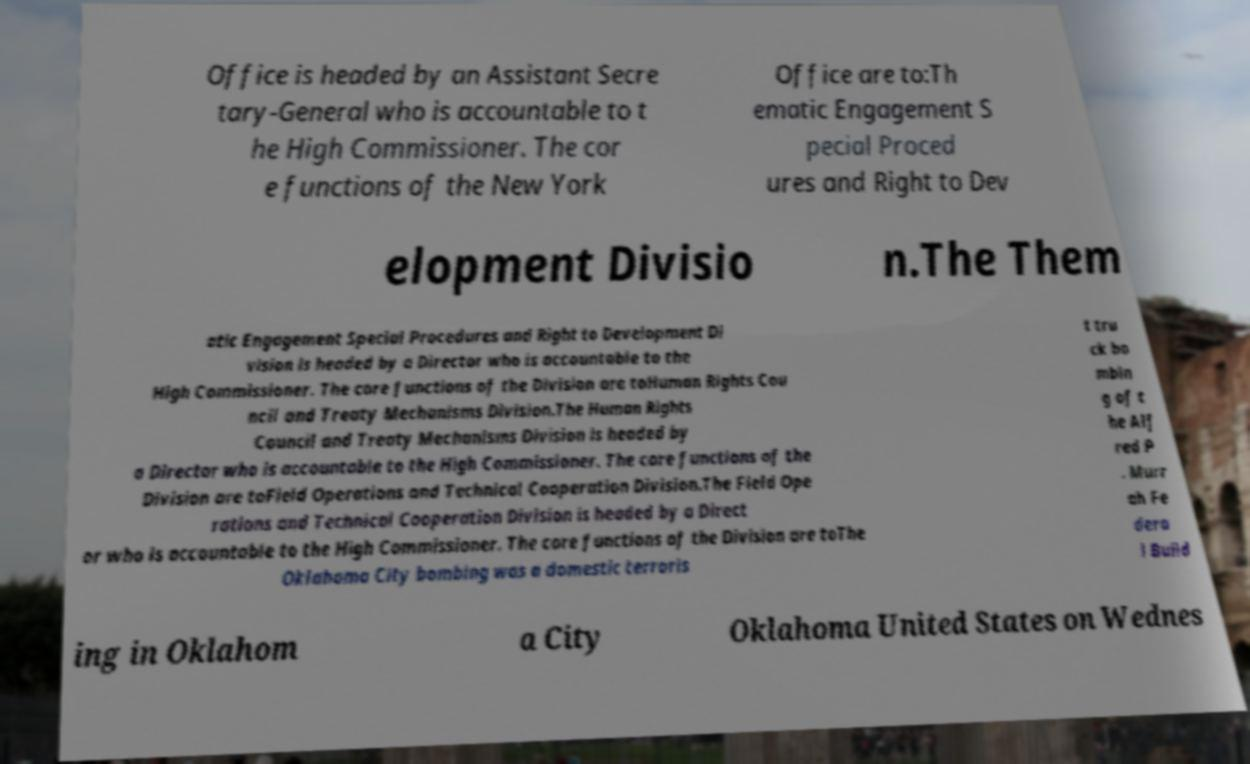Can you accurately transcribe the text from the provided image for me? Office is headed by an Assistant Secre tary-General who is accountable to t he High Commissioner. The cor e functions of the New York Office are to:Th ematic Engagement S pecial Proced ures and Right to Dev elopment Divisio n.The Them atic Engagement Special Procedures and Right to Development Di vision is headed by a Director who is accountable to the High Commissioner. The core functions of the Division are toHuman Rights Cou ncil and Treaty Mechanisms Division.The Human Rights Council and Treaty Mechanisms Division is headed by a Director who is accountable to the High Commissioner. The core functions of the Division are toField Operations and Technical Cooperation Division.The Field Ope rations and Technical Cooperation Division is headed by a Direct or who is accountable to the High Commissioner. The core functions of the Division are toThe Oklahoma City bombing was a domestic terroris t tru ck bo mbin g of t he Alf red P . Murr ah Fe dera l Build ing in Oklahom a City Oklahoma United States on Wednes 